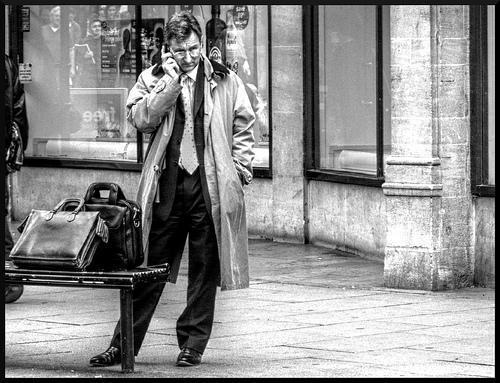How many handbags are there?
Give a very brief answer. 2. How many people are there?
Give a very brief answer. 2. How many elephants are under a tree branch?
Give a very brief answer. 0. 